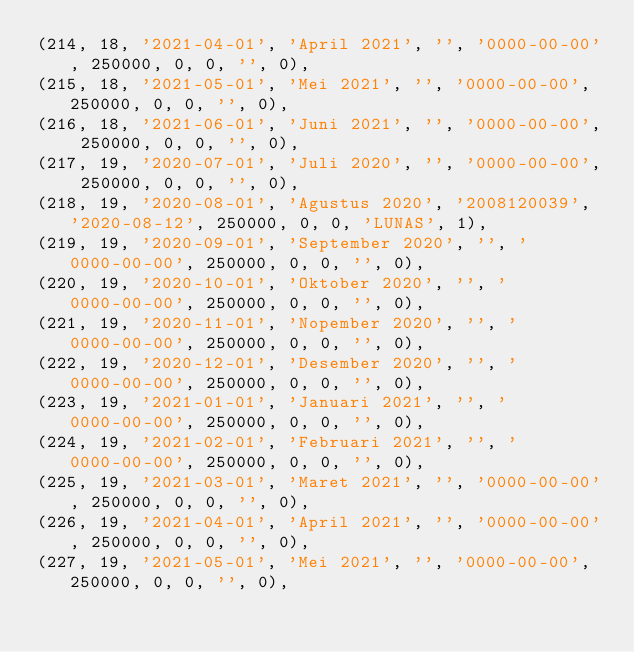<code> <loc_0><loc_0><loc_500><loc_500><_SQL_>(214, 18, '2021-04-01', 'April 2021', '', '0000-00-00', 250000, 0, 0, '', 0),
(215, 18, '2021-05-01', 'Mei 2021', '', '0000-00-00', 250000, 0, 0, '', 0),
(216, 18, '2021-06-01', 'Juni 2021', '', '0000-00-00', 250000, 0, 0, '', 0),
(217, 19, '2020-07-01', 'Juli 2020', '', '0000-00-00', 250000, 0, 0, '', 0),
(218, 19, '2020-08-01', 'Agustus 2020', '2008120039', '2020-08-12', 250000, 0, 0, 'LUNAS', 1),
(219, 19, '2020-09-01', 'September 2020', '', '0000-00-00', 250000, 0, 0, '', 0),
(220, 19, '2020-10-01', 'Oktober 2020', '', '0000-00-00', 250000, 0, 0, '', 0),
(221, 19, '2020-11-01', 'Nopember 2020', '', '0000-00-00', 250000, 0, 0, '', 0),
(222, 19, '2020-12-01', 'Desember 2020', '', '0000-00-00', 250000, 0, 0, '', 0),
(223, 19, '2021-01-01', 'Januari 2021', '', '0000-00-00', 250000, 0, 0, '', 0),
(224, 19, '2021-02-01', 'Februari 2021', '', '0000-00-00', 250000, 0, 0, '', 0),
(225, 19, '2021-03-01', 'Maret 2021', '', '0000-00-00', 250000, 0, 0, '', 0),
(226, 19, '2021-04-01', 'April 2021', '', '0000-00-00', 250000, 0, 0, '', 0),
(227, 19, '2021-05-01', 'Mei 2021', '', '0000-00-00', 250000, 0, 0, '', 0),</code> 